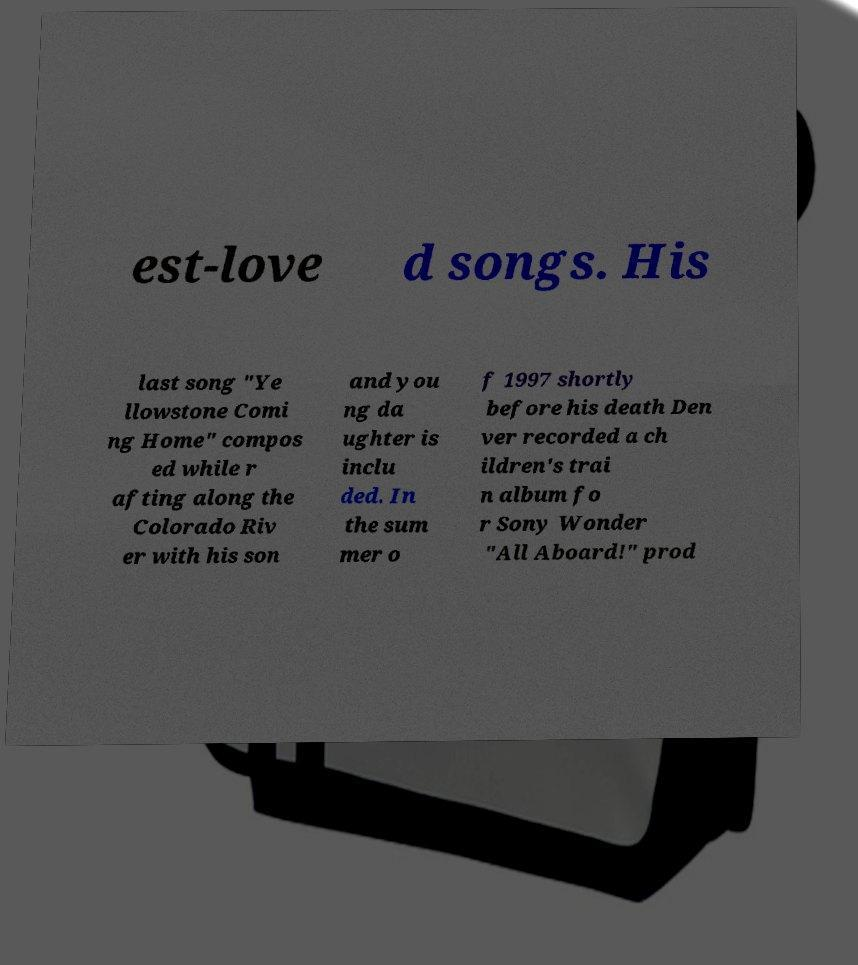Could you assist in decoding the text presented in this image and type it out clearly? est-love d songs. His last song "Ye llowstone Comi ng Home" compos ed while r afting along the Colorado Riv er with his son and you ng da ughter is inclu ded. In the sum mer o f 1997 shortly before his death Den ver recorded a ch ildren's trai n album fo r Sony Wonder "All Aboard!" prod 